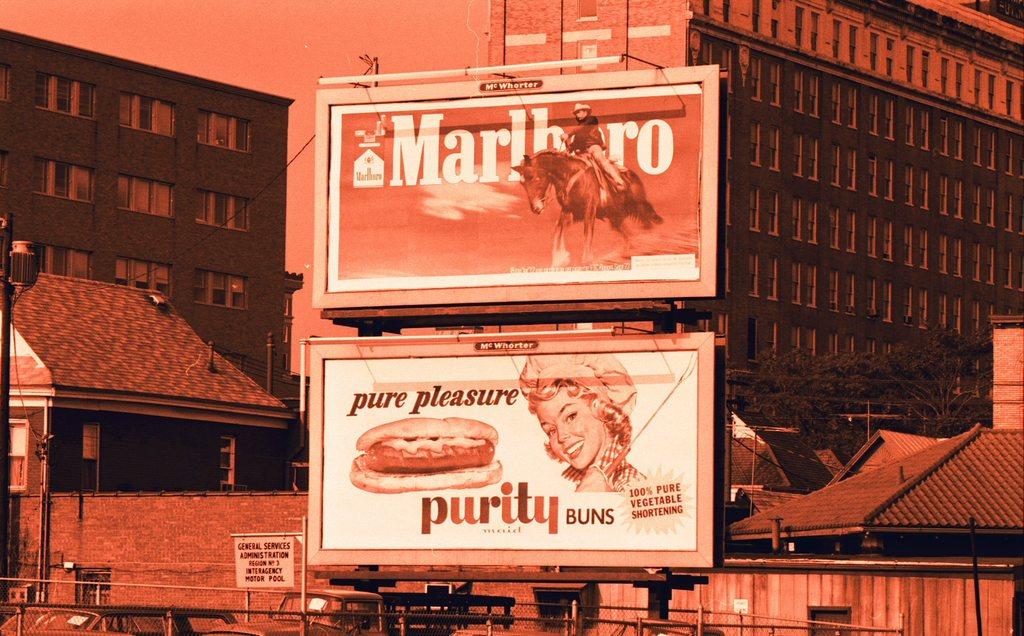What is the ad on the top for?
Provide a short and direct response. Marlboro. 